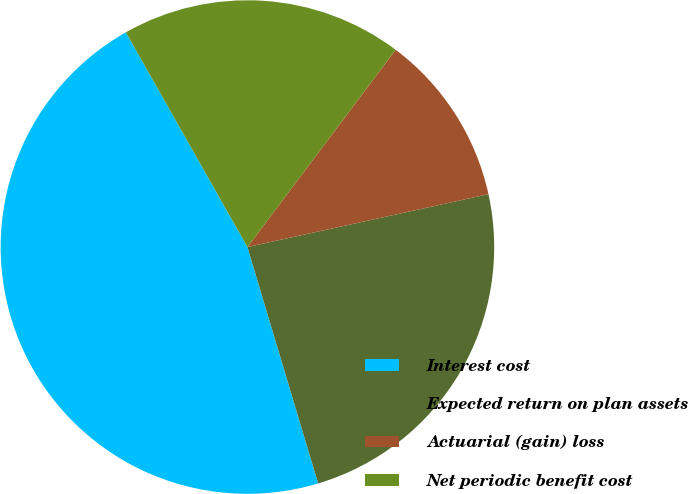<chart> <loc_0><loc_0><loc_500><loc_500><pie_chart><fcel>Interest cost<fcel>Expected return on plan assets<fcel>Actuarial (gain) loss<fcel>Net periodic benefit cost<nl><fcel>46.43%<fcel>23.81%<fcel>11.31%<fcel>18.45%<nl></chart> 